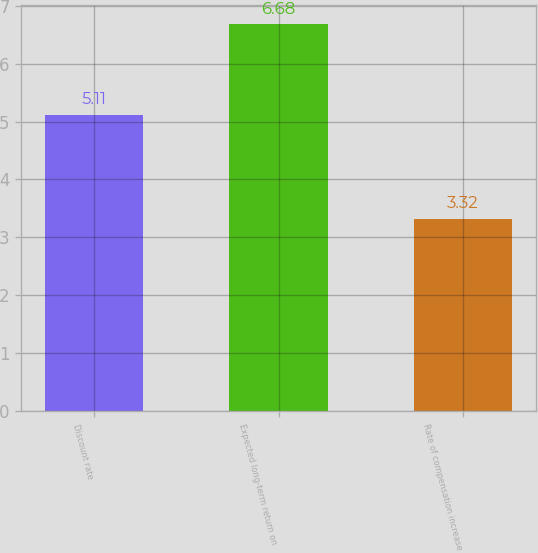Convert chart to OTSL. <chart><loc_0><loc_0><loc_500><loc_500><bar_chart><fcel>Discount rate<fcel>Expected long-term return on<fcel>Rate of compensation increase<nl><fcel>5.11<fcel>6.68<fcel>3.32<nl></chart> 